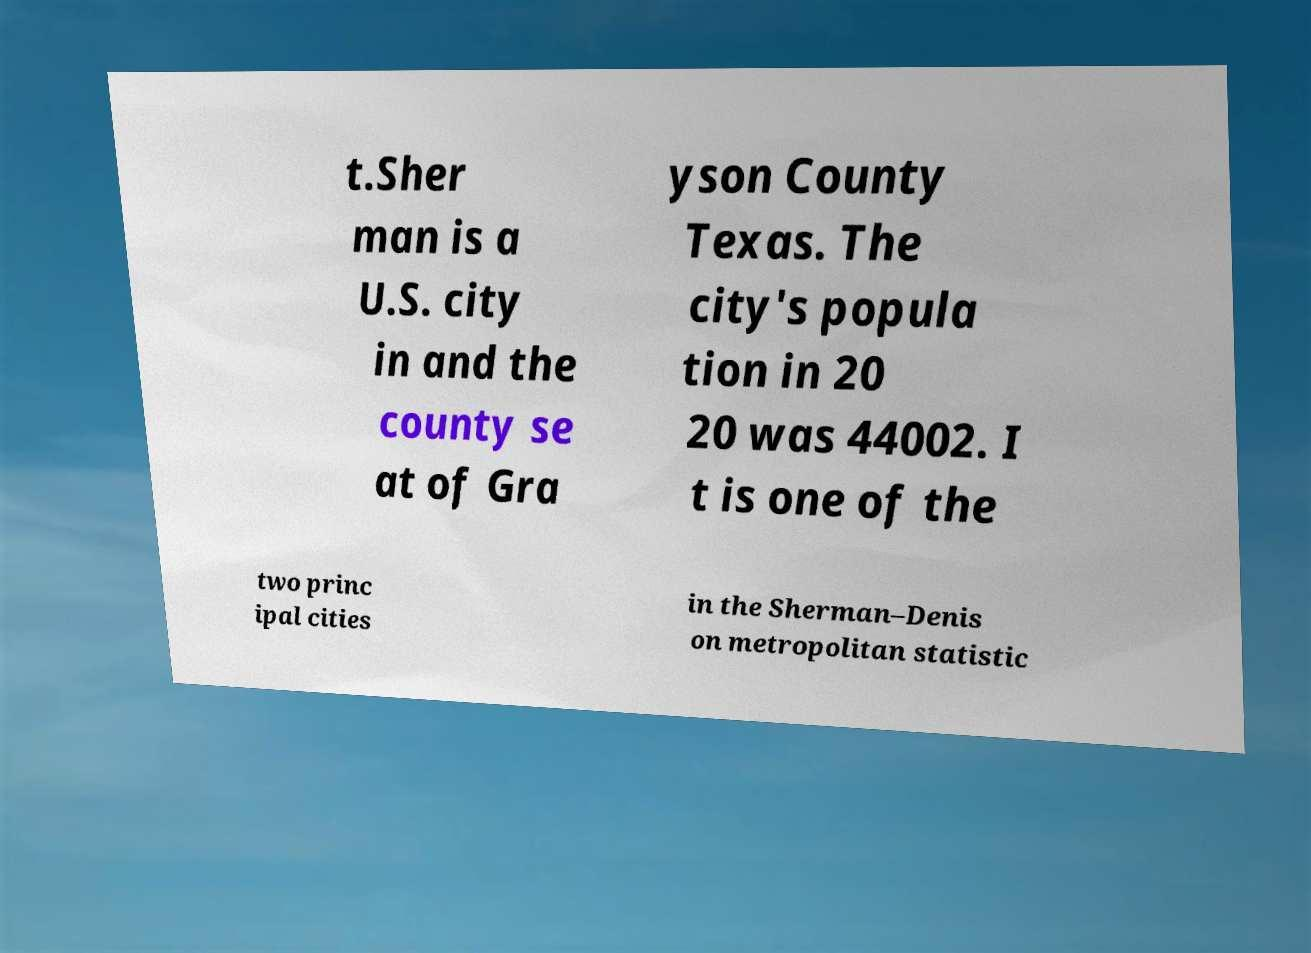For documentation purposes, I need the text within this image transcribed. Could you provide that? t.Sher man is a U.S. city in and the county se at of Gra yson County Texas. The city's popula tion in 20 20 was 44002. I t is one of the two princ ipal cities in the Sherman–Denis on metropolitan statistic 